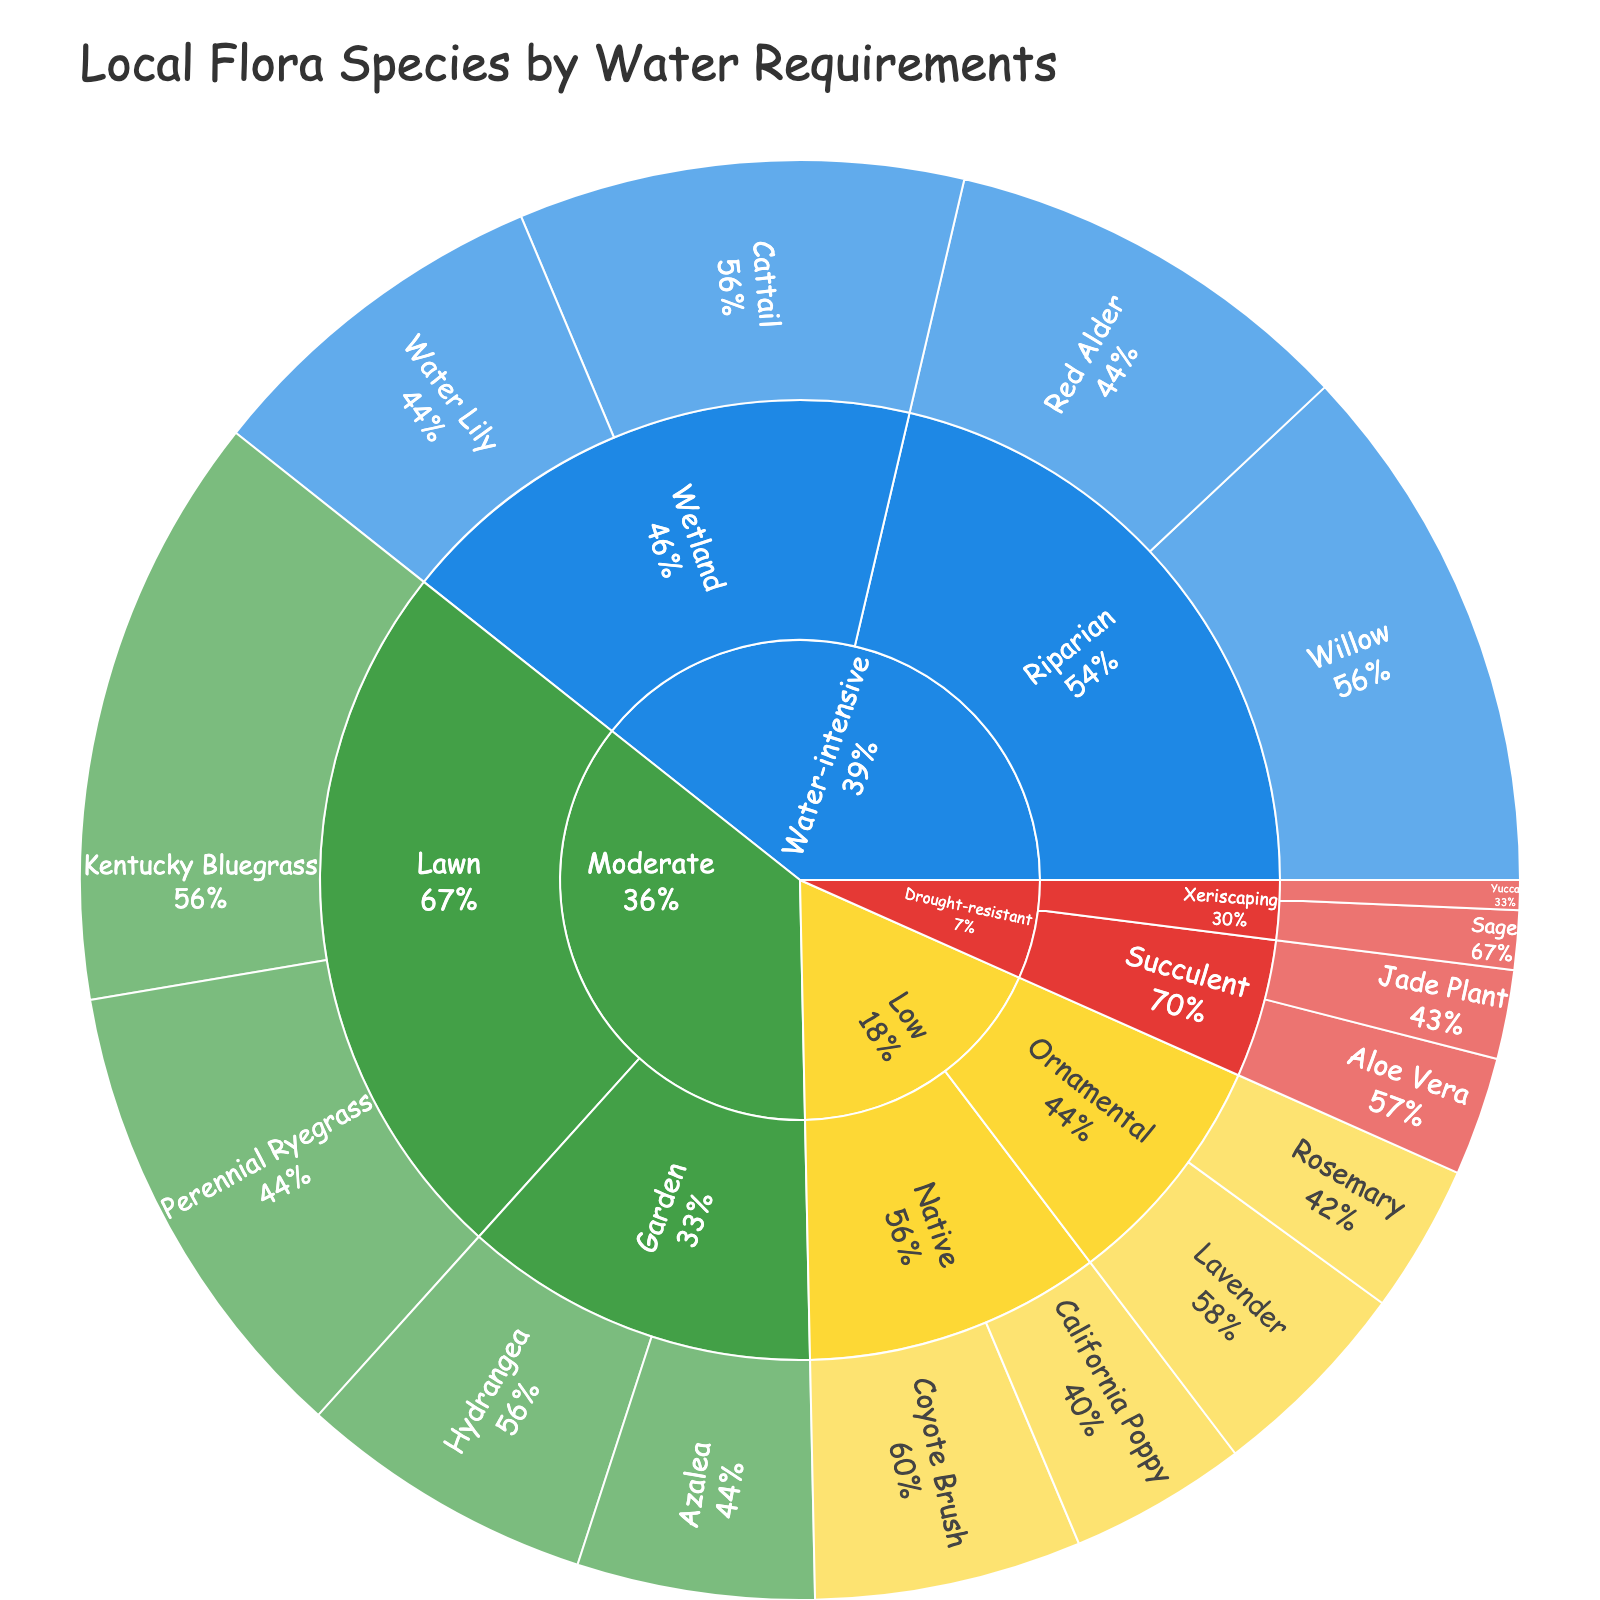what is the title of the plot? The top of the plot displays the title that describes the figure. Here, it's "Local Flora Species by Water Requirements".
Answer: Local Flora Species by Water Requirements How many species belong to the drought-resistant category? In the Drought-resistant section of the sunburst plot, there are three subcategories: Succulent and Xeriscaping. Summing the values, we have Aloe Vera (4), Jade Plant (3), Sage (2), and Yucca (1), so 4 species in total.
Answer: 4 Which subcategory within the Water-intensive category has the highest value? The Water-intensive category splits into Wetland and Riparian subcategories. Riparian has Willow (18) and Red Alder (14), totaling 32. Wetland has Cattail (15) and Water Lily (12), totaling 27. Riparian has the highest value.
Answer: Riparian what’s the value of the species with the lowest water requirement? The sunburst plot shows the Drought-resistant category species requiring the least water. Yucca in the Xeriscaping subcategory has a value of 1, which is the lowest.
Answer: 1 How does the value of the Willow species compare to the combined value of Hydrangea and Azalea? We first find the Willow value, which is 18. Then, we add Hydrangea (10) and Azalea (8), getting 18. Since 18 is equal to 18, the Willow value equals the combined value of Hydrangea and Azalea.
Answer: Equal Which category has more species, Moderate or Low? The Moderate category includes Hydrangea, Azalea, Kentucky Bluegrass, and Perennial Ryegrass, giving 4 species. The Low category includes California Poppy, Coyote Brush, Lavender, and Rosemary, also resulting in 4 species. Therefore, they have the same number of species.
Answer: Same What is the proportion of the Lawn subcategory in the Moderate category? The Lawn subcategory has Kentucky Bluegrass (20) and Perennial Ryegrass (16), so 36 in total. The Moderate category totals 20 (Lawn) + 18 (Garden), making 54. To find the proportion: 36/54 = 2/3 ≈ 67%.
Answer: 67% For a plant that requires moderate water, what’s the most common subcategory? In the Moderate category, we compare the Garden subcategory with Hydrangea (10) and Azalea (8), totaling 18, against the Lawn subcategory with Kentucky Bluegrass (20) and Perennial Ryegrass (16), totaling 36. Lawn is the most common subcategory.
Answer: Lawn Which has a higher total value: Native under Low or Riparian under Water-intensive? Adding the Low category Native values gives California Poppy (6) + Coyote Brush (9) = 15. The Riparian values sum to Willow (18) + Red Alder (14) = 32. Riparian under Water-intensive has a higher total value.
Answer: Riparian under Water-intensive What percentage of the total species in the plot belong to the Wetland subcategory in Water-intensive? The Wetland subcategory has Cattail (15) + Water Lily (12) = 27. The total plot sum is 15 (Cattail) + 12 (Water Lily) + 18 (Willow) + 14 (Red Alder) + 10 (Hydrangea) + 8 (Azalea) + 20 (Kentucky Bluegrass) + 16 (Perennial Ryegrass) + 6 (California Poppy) + 9 (Coyote Brush) + 7 (Lavender) + 5 (Rosemary) + 4 (Aloe Vera) + 3 (Jade Plant) + 2 (Sage) + 1 (Yucca) = 150. Value percentage is (27 / 150) * 100 ≈ 18%.
Answer: 18% 